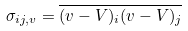<formula> <loc_0><loc_0><loc_500><loc_500>\sigma _ { i j , v } = \overline { ( v - V ) _ { i } ( v - V ) _ { j } }</formula> 